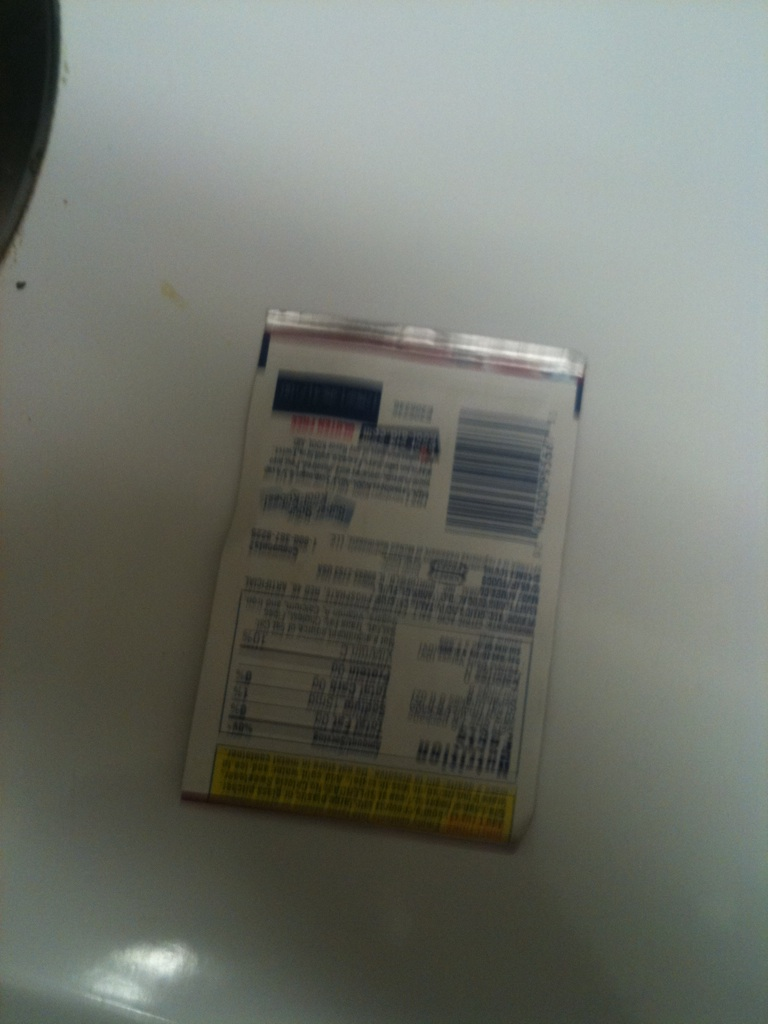Can you write a short fictional story featuring this package in an enchanted kitchen? In a quaint little house on the edge of a mystical forest, there lived a magical cook named Elara. Her enchanted kitchen was famous for the glowing jars of spices and ingredients, each with a life of its own. Among these jars was a humble package of mysterious spice. One day, Elara discovered that this spice had the power to make dishes sing with a melodious tune. With it, she created a dish that enchanted every villager who tasted it, filling them with joy and a sense of wonder. The package wasn't just a container; it was a keeper of magic that brought harmony to everyone through its culinary melodies. 